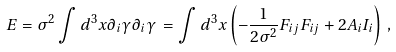<formula> <loc_0><loc_0><loc_500><loc_500>E = \sigma ^ { 2 } \int d ^ { 3 } x \partial _ { i } \gamma \partial _ { i } \gamma \, = \int d ^ { 3 } x \left ( - \frac { 1 } { 2 \sigma ^ { 2 } } F _ { i j } F _ { i j } + 2 A _ { i } I _ { i } \right ) \, ,</formula> 